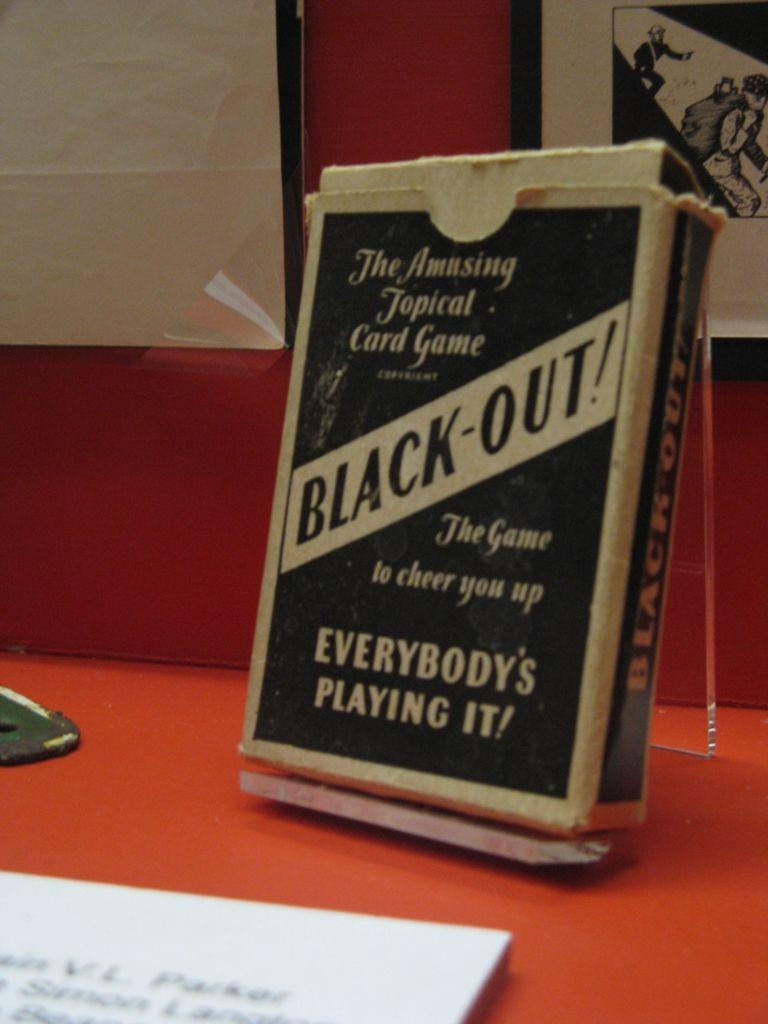<image>
Create a compact narrative representing the image presented. A very old card packet with Black-out! on the front sit on display in front of an info card. 